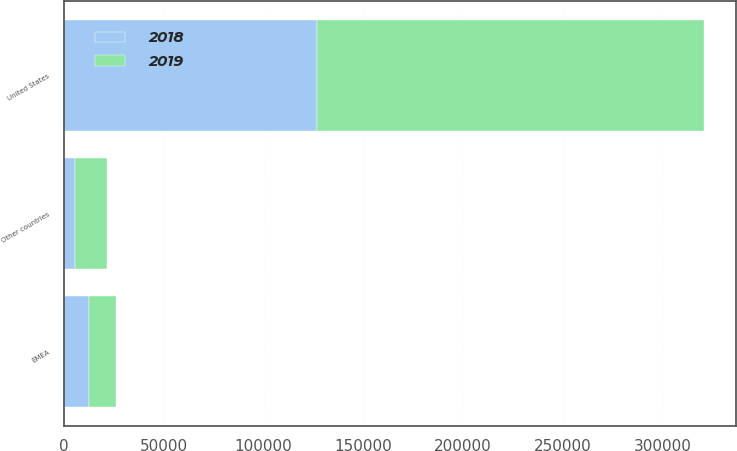Convert chart to OTSL. <chart><loc_0><loc_0><loc_500><loc_500><stacked_bar_chart><ecel><fcel>United States<fcel>EMEA<fcel>Other countries<nl><fcel>2019<fcel>194176<fcel>13451<fcel>15799<nl><fcel>2018<fcel>126790<fcel>12538<fcel>5714<nl></chart> 